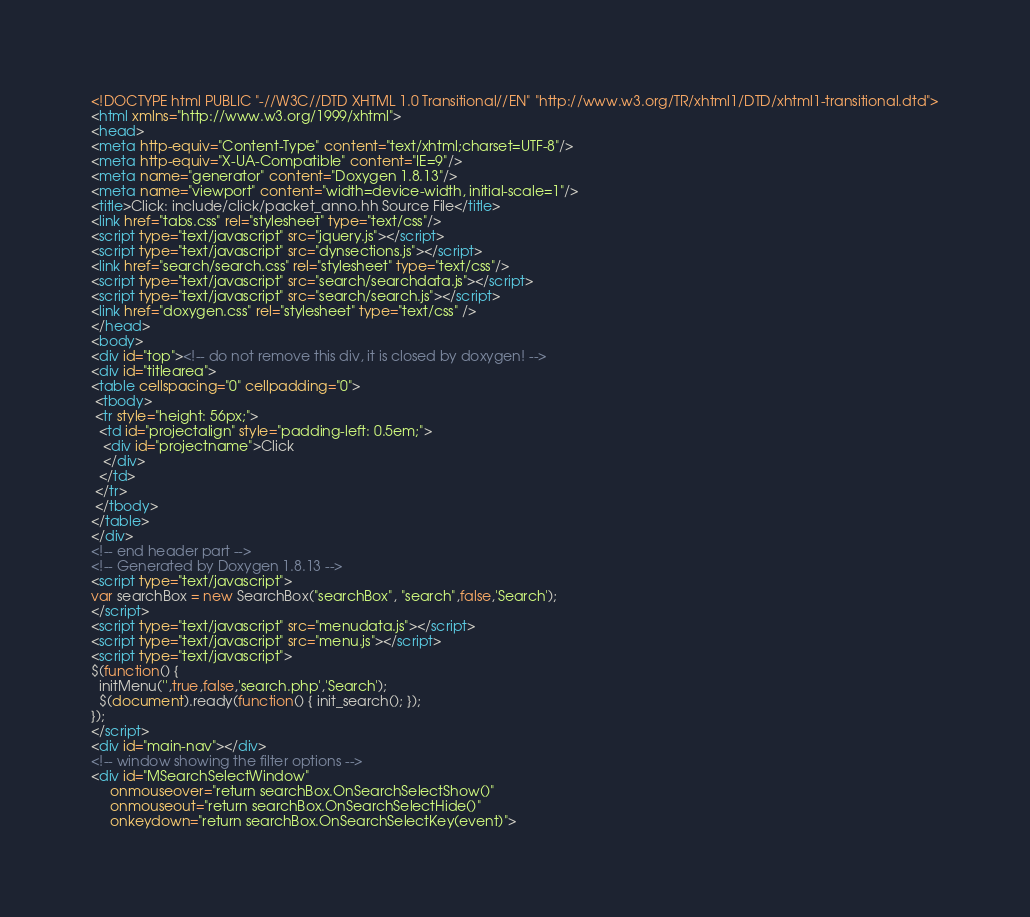<code> <loc_0><loc_0><loc_500><loc_500><_HTML_><!DOCTYPE html PUBLIC "-//W3C//DTD XHTML 1.0 Transitional//EN" "http://www.w3.org/TR/xhtml1/DTD/xhtml1-transitional.dtd">
<html xmlns="http://www.w3.org/1999/xhtml">
<head>
<meta http-equiv="Content-Type" content="text/xhtml;charset=UTF-8"/>
<meta http-equiv="X-UA-Compatible" content="IE=9"/>
<meta name="generator" content="Doxygen 1.8.13"/>
<meta name="viewport" content="width=device-width, initial-scale=1"/>
<title>Click: include/click/packet_anno.hh Source File</title>
<link href="tabs.css" rel="stylesheet" type="text/css"/>
<script type="text/javascript" src="jquery.js"></script>
<script type="text/javascript" src="dynsections.js"></script>
<link href="search/search.css" rel="stylesheet" type="text/css"/>
<script type="text/javascript" src="search/searchdata.js"></script>
<script type="text/javascript" src="search/search.js"></script>
<link href="doxygen.css" rel="stylesheet" type="text/css" />
</head>
<body>
<div id="top"><!-- do not remove this div, it is closed by doxygen! -->
<div id="titlearea">
<table cellspacing="0" cellpadding="0">
 <tbody>
 <tr style="height: 56px;">
  <td id="projectalign" style="padding-left: 0.5em;">
   <div id="projectname">Click
   </div>
  </td>
 </tr>
 </tbody>
</table>
</div>
<!-- end header part -->
<!-- Generated by Doxygen 1.8.13 -->
<script type="text/javascript">
var searchBox = new SearchBox("searchBox", "search",false,'Search');
</script>
<script type="text/javascript" src="menudata.js"></script>
<script type="text/javascript" src="menu.js"></script>
<script type="text/javascript">
$(function() {
  initMenu('',true,false,'search.php','Search');
  $(document).ready(function() { init_search(); });
});
</script>
<div id="main-nav"></div>
<!-- window showing the filter options -->
<div id="MSearchSelectWindow"
     onmouseover="return searchBox.OnSearchSelectShow()"
     onmouseout="return searchBox.OnSearchSelectHide()"
     onkeydown="return searchBox.OnSearchSelectKey(event)"></code> 